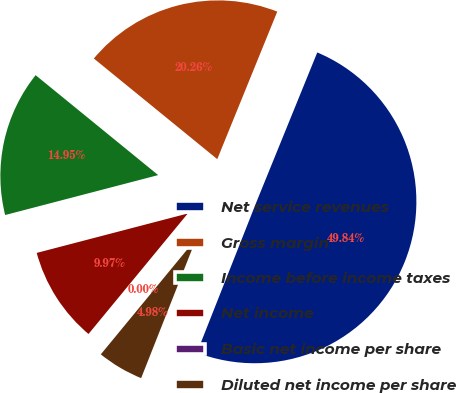Convert chart. <chart><loc_0><loc_0><loc_500><loc_500><pie_chart><fcel>Net service revenues<fcel>Gross margin<fcel>Income before income taxes<fcel>Net income<fcel>Basic net income per share<fcel>Diluted net income per share<nl><fcel>49.84%<fcel>20.26%<fcel>14.95%<fcel>9.97%<fcel>0.0%<fcel>4.98%<nl></chart> 